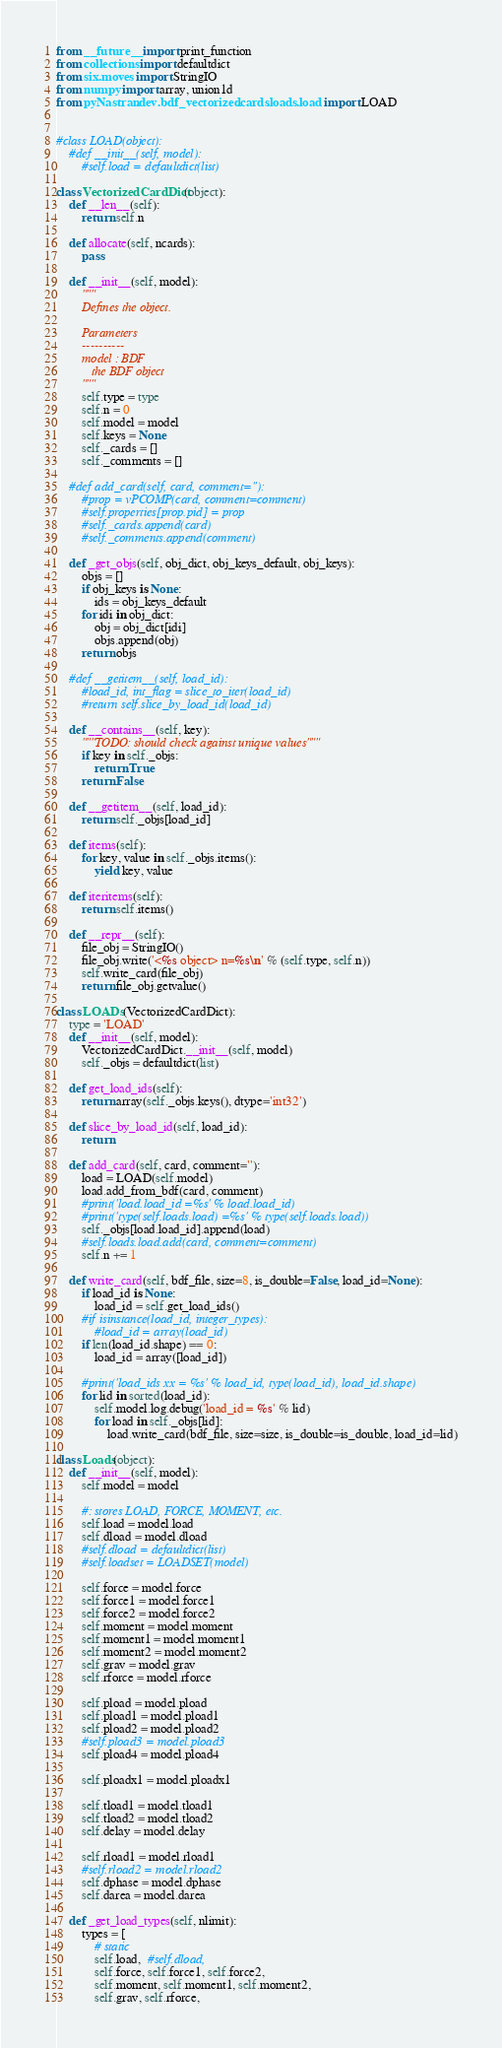<code> <loc_0><loc_0><loc_500><loc_500><_Python_>from __future__ import print_function
from collections import defaultdict
from six.moves import StringIO
from numpy import array, union1d
from pyNastran.dev.bdf_vectorized.cards.loads.load import LOAD


#class LOAD(object):
    #def __init__(self, model):
        #self.load = defaultdict(list)

class VectorizedCardDict(object):
    def __len__(self):
        return self.n

    def allocate(self, ncards):
        pass

    def __init__(self, model):
        """
        Defines the object.

        Parameters
        ----------
        model : BDF
           the BDF object
        """
        self.type = type
        self.n = 0
        self.model = model
        self.keys = None
        self._cards = []
        self._comments = []

    #def add_card(self, card, comment=''):
        #prop = vPCOMP(card, comment=comment)
        #self.properties[prop.pid] = prop
        #self._cards.append(card)
        #self._comments.append(comment)

    def _get_objs(self, obj_dict, obj_keys_default, obj_keys):
        objs = []
        if obj_keys is None:
            ids = obj_keys_default
        for idi in obj_dict:
            obj = obj_dict[idi]
            objs.append(obj)
        return objs

    #def __getitem__(self, load_id):
        #load_id, int_flag = slice_to_iter(load_id)
        #return self.slice_by_load_id(load_id)

    def __contains__(self, key):
        """TODO: should check against unique values"""
        if key in self._objs:
            return True
        return False

    def __getitem__(self, load_id):
        return self._objs[load_id]

    def items(self):
        for key, value in self._objs.items():
            yield key, value

    def iteritems(self):
        return self.items()

    def __repr__(self):
        file_obj = StringIO()
        file_obj.write('<%s object> n=%s\n' % (self.type, self.n))
        self.write_card(file_obj)
        return file_obj.getvalue()

class LOADs(VectorizedCardDict):
    type = 'LOAD'
    def __init__(self, model):
        VectorizedCardDict.__init__(self, model)
        self._objs = defaultdict(list)

    def get_load_ids(self):
        return array(self._objs.keys(), dtype='int32')

    def slice_by_load_id(self, load_id):
        return

    def add_card(self, card, comment=''):
        load = LOAD(self.model)
        load.add_from_bdf(card, comment)
        #print('load.load_id =%s' % load.load_id)
        #print('type(self.loads.load) =%s' % type(self.loads.load))
        self._objs[load.load_id].append(load)
        #self.loads.load.add(card, comment=comment)
        self.n += 1

    def write_card(self, bdf_file, size=8, is_double=False, load_id=None):
        if load_id is None:
            load_id = self.get_load_ids()
        #if isinstance(load_id, integer_types):
            #load_id = array(load_id)
        if len(load_id.shape) == 0:
            load_id = array([load_id])

        #print('load_ids xx = %s' % load_id, type(load_id), load_id.shape)
        for lid in sorted(load_id):
            self.model.log.debug('load_id = %s' % lid)
            for load in self._objs[lid]:
                load.write_card(bdf_file, size=size, is_double=is_double, load_id=lid)

class Loads(object):
    def __init__(self, model):
        self.model = model

        #: stores LOAD, FORCE, MOMENT, etc.
        self.load = model.load
        self.dload = model.dload
        #self.dload = defaultdict(list)
        #self.loadset = LOADSET(model)

        self.force = model.force
        self.force1 = model.force1
        self.force2 = model.force2
        self.moment = model.moment
        self.moment1 = model.moment1
        self.moment2 = model.moment2
        self.grav = model.grav
        self.rforce = model.rforce

        self.pload = model.pload
        self.pload1 = model.pload1
        self.pload2 = model.pload2
        #self.pload3 = model.pload3
        self.pload4 = model.pload4

        self.ploadx1 = model.ploadx1

        self.tload1 = model.tload1
        self.tload2 = model.tload2
        self.delay = model.delay

        self.rload1 = model.rload1
        #self.rload2 = model.rload2
        self.dphase = model.dphase
        self.darea = model.darea

    def _get_load_types(self, nlimit):
        types = [
            # static
            self.load,  #self.dload,
            self.force, self.force1, self.force2,
            self.moment, self.moment1, self.moment2,
            self.grav, self.rforce,</code> 